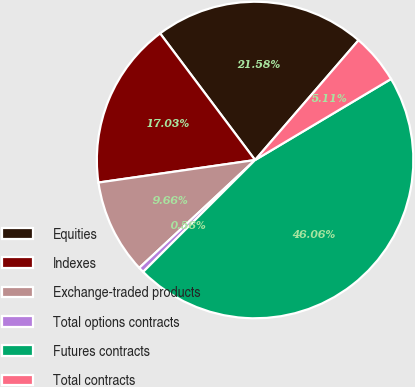<chart> <loc_0><loc_0><loc_500><loc_500><pie_chart><fcel>Equities<fcel>Indexes<fcel>Exchange-traded products<fcel>Total options contracts<fcel>Futures contracts<fcel>Total contracts<nl><fcel>21.58%<fcel>17.03%<fcel>9.66%<fcel>0.56%<fcel>46.06%<fcel>5.11%<nl></chart> 